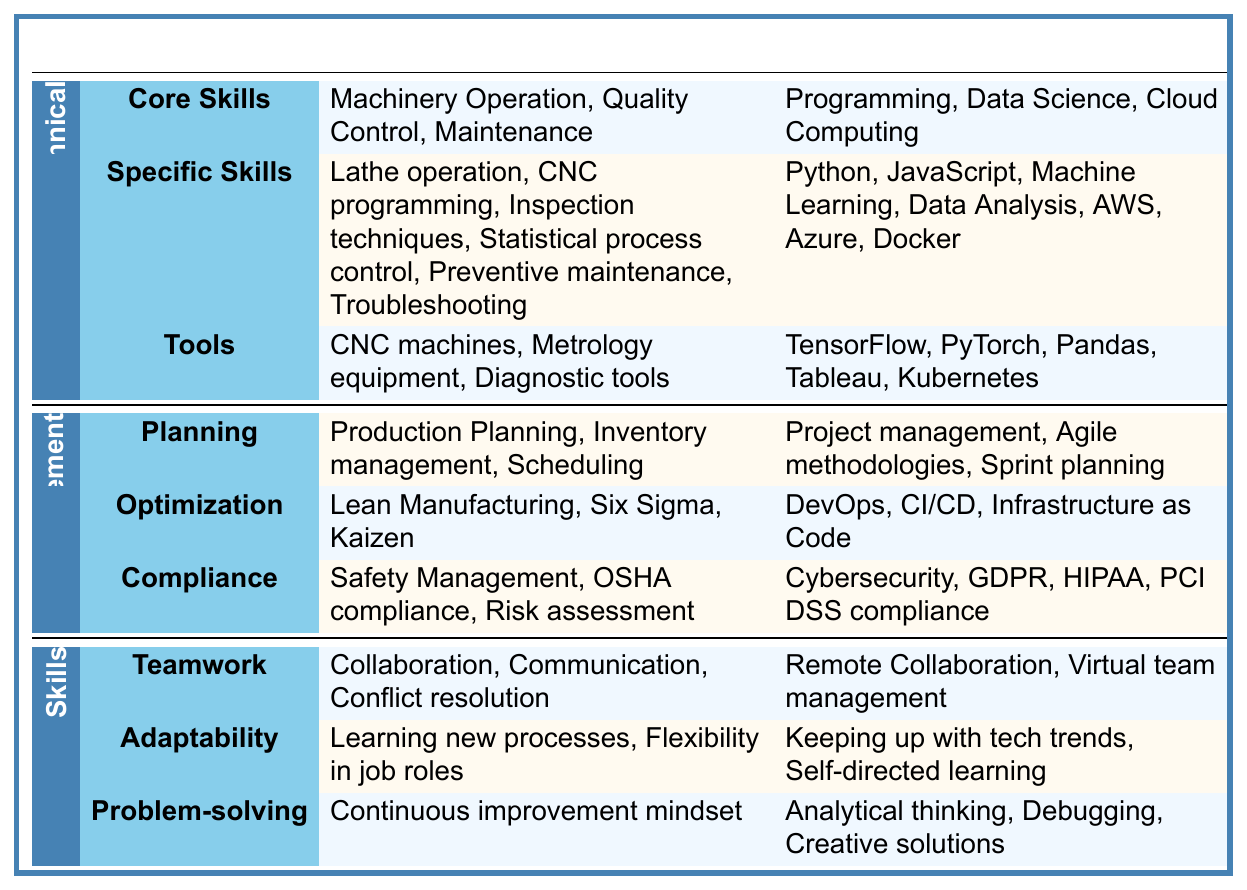What are the core technical skills required in traditional manufacturing? From the table, the core technical skills listed under traditional manufacturing are Machinery Operation, Quality Control, and Maintenance.
Answer: Machinery Operation, Quality Control, Maintenance Which emerging tech skill category includes statistical analysis? The emerging tech skill category that includes statistical analysis is Data Science, as indicated by the specific skills listed under that category.
Answer: Data Science How many specific skills are listed under traditional manufacturing? Traditional manufacturing has six specific skills: Lathe operation, CNC programming, Inspection techniques, Statistical process control, Preventive maintenance, and Troubleshooting.
Answer: 6 Is 'Debugging' considered a soft skill in emerging tech roles? Yes, 'Debugging' is mentioned under the Problem-solving soft skill category in emerging tech roles.
Answer: Yes In comparison to traditional manufacturing, which role has a focus on 'Continuous Learning'? Emerging tech roles emphasize Continuous Learning while traditional manufacturing focuses more on adaptability and teamwork.
Answer: Emerging tech roles How many core skills are listed under management for traditional manufacturing? There are three core skills listed under the management category for traditional manufacturing: Planning, Optimization, and Compliance.
Answer: 3 Which category in emerging tech has the most specific skills listed? Programming appears to have the most specific skills listed, with multiple specific skills related to Languages, Web Development, and Mobile Development.
Answer: Programming Is there a compliance aspect in the management skills of traditional manufacturing? Yes, Safety Management and OSHA compliance are included under the Compliance aspect in the management skills for traditional manufacturing.
Answer: Yes If we add up all the soft skill categories in both traditional manufacturing and emerging tech, how many categories do we have? There are three soft skill categories in traditional manufacturing and three in emerging tech, which sum up to a total of six soft skill categories.
Answer: 6 Which specific tool is mentioned under traditional manufacturing technical skills? The tools listed under traditional manufacturing include CNC machines, Metrology equipment, and Diagnostic tools.
Answer: CNC machines, Metrology equipment, Diagnostic tools 